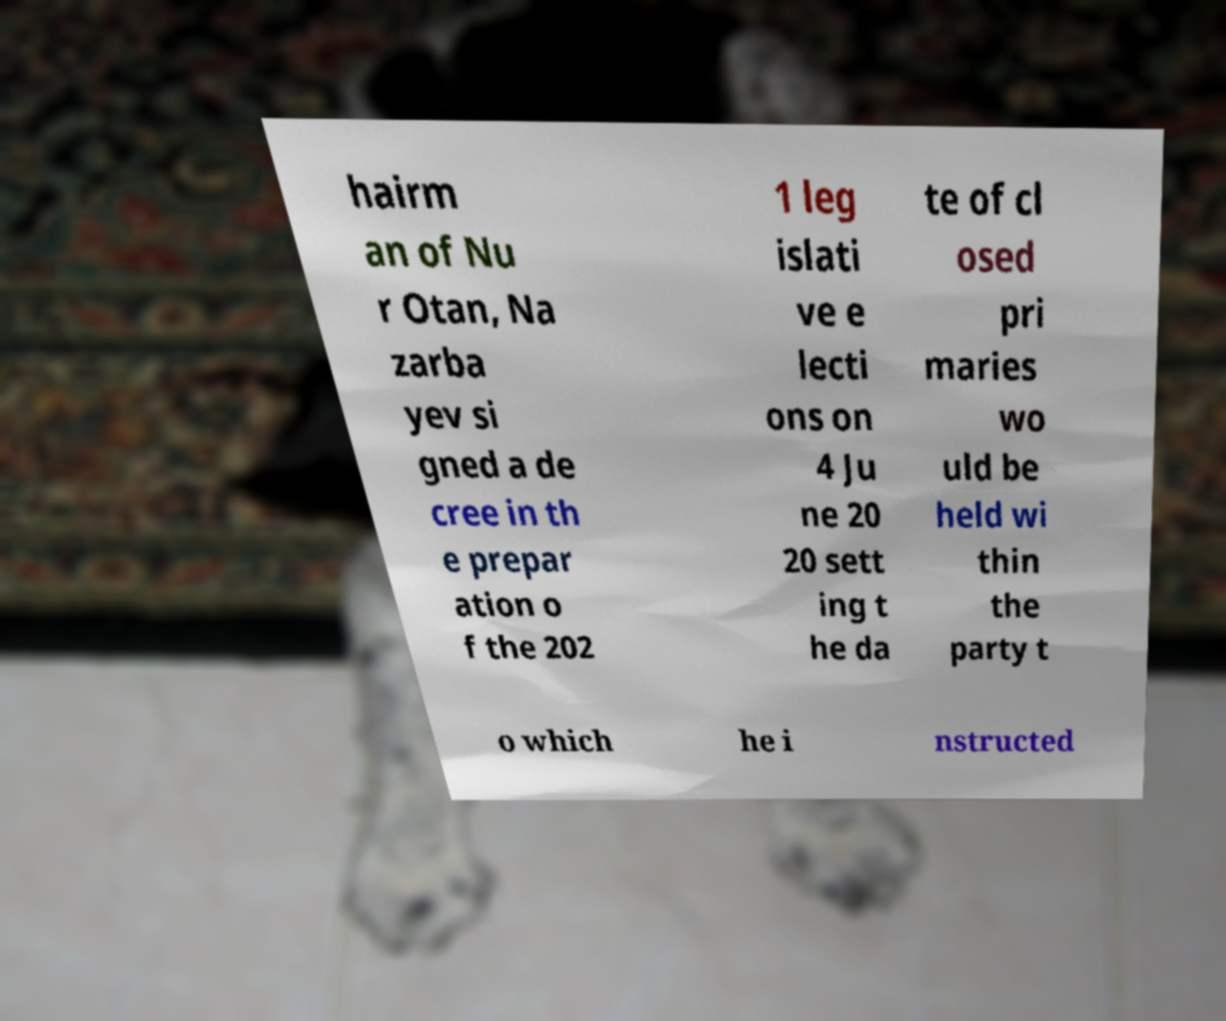There's text embedded in this image that I need extracted. Can you transcribe it verbatim? hairm an of Nu r Otan, Na zarba yev si gned a de cree in th e prepar ation o f the 202 1 leg islati ve e lecti ons on 4 Ju ne 20 20 sett ing t he da te of cl osed pri maries wo uld be held wi thin the party t o which he i nstructed 